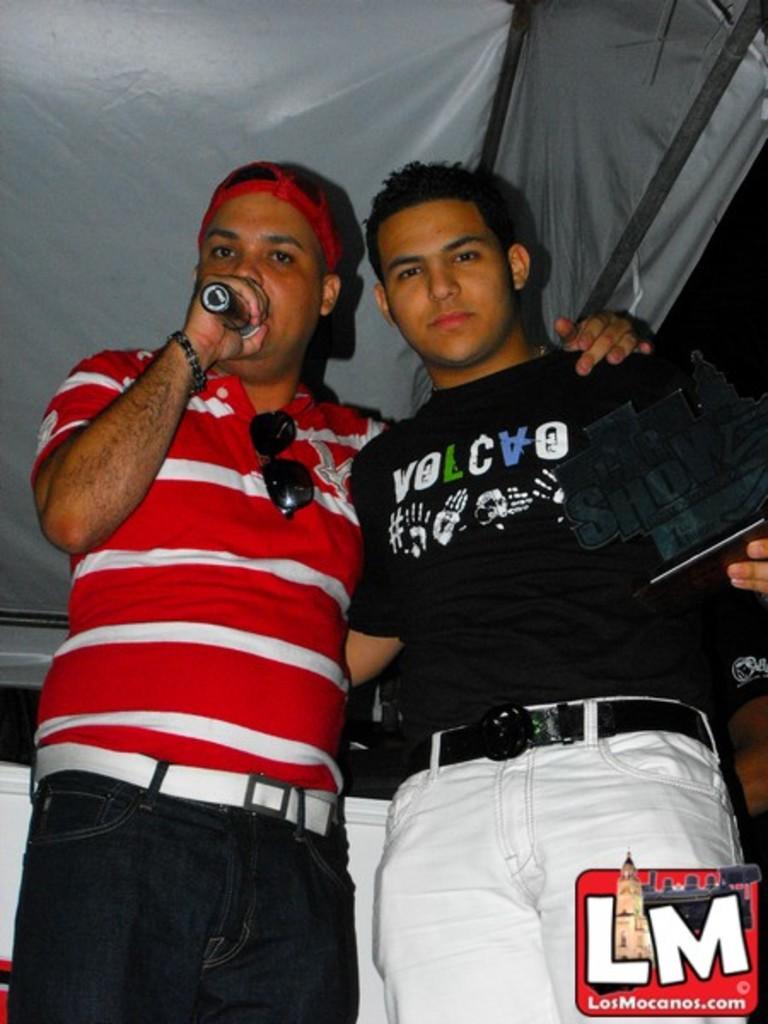What is the website in the corner?
Ensure brevity in your answer.  Losmocanos.com. What does the black shirt say?
Provide a succinct answer. Volcvo. 